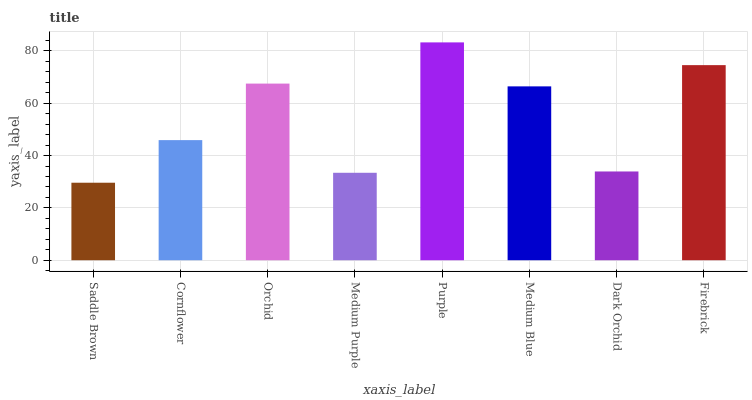Is Cornflower the minimum?
Answer yes or no. No. Is Cornflower the maximum?
Answer yes or no. No. Is Cornflower greater than Saddle Brown?
Answer yes or no. Yes. Is Saddle Brown less than Cornflower?
Answer yes or no. Yes. Is Saddle Brown greater than Cornflower?
Answer yes or no. No. Is Cornflower less than Saddle Brown?
Answer yes or no. No. Is Medium Blue the high median?
Answer yes or no. Yes. Is Cornflower the low median?
Answer yes or no. Yes. Is Purple the high median?
Answer yes or no. No. Is Medium Blue the low median?
Answer yes or no. No. 